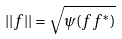Convert formula to latex. <formula><loc_0><loc_0><loc_500><loc_500>| | f | | = \sqrt { \psi ( f f ^ { * } ) }</formula> 